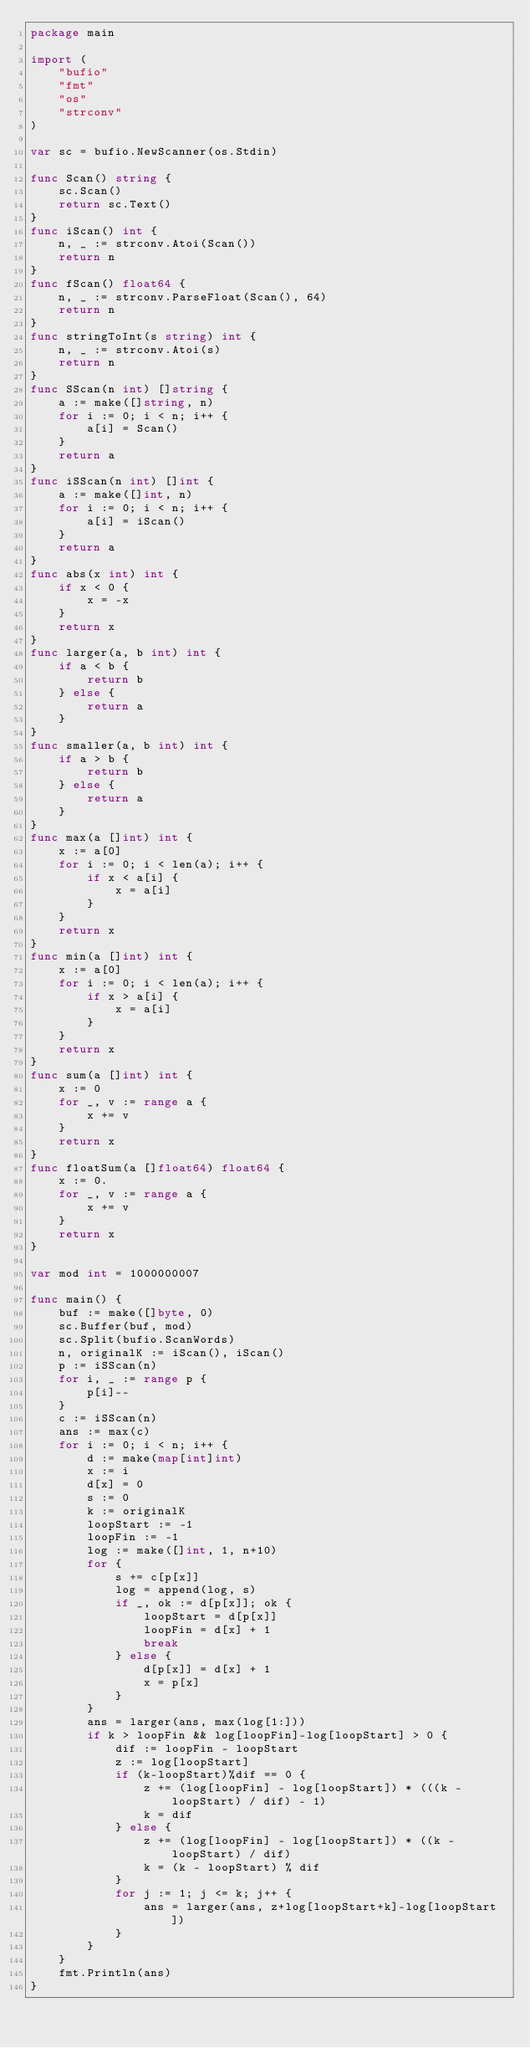Convert code to text. <code><loc_0><loc_0><loc_500><loc_500><_Go_>package main

import (
	"bufio"
	"fmt"
	"os"
	"strconv"
)

var sc = bufio.NewScanner(os.Stdin)

func Scan() string {
	sc.Scan()
	return sc.Text()
}
func iScan() int {
	n, _ := strconv.Atoi(Scan())
	return n
}
func fScan() float64 {
	n, _ := strconv.ParseFloat(Scan(), 64)
	return n
}
func stringToInt(s string) int {
	n, _ := strconv.Atoi(s)
	return n
}
func SScan(n int) []string {
	a := make([]string, n)
	for i := 0; i < n; i++ {
		a[i] = Scan()
	}
	return a
}
func iSScan(n int) []int {
	a := make([]int, n)
	for i := 0; i < n; i++ {
		a[i] = iScan()
	}
	return a
}
func abs(x int) int {
	if x < 0 {
		x = -x
	}
	return x
}
func larger(a, b int) int {
	if a < b {
		return b
	} else {
		return a
	}
}
func smaller(a, b int) int {
	if a > b {
		return b
	} else {
		return a
	}
}
func max(a []int) int {
	x := a[0]
	for i := 0; i < len(a); i++ {
		if x < a[i] {
			x = a[i]
		}
	}
	return x
}
func min(a []int) int {
	x := a[0]
	for i := 0; i < len(a); i++ {
		if x > a[i] {
			x = a[i]
		}
	}
	return x
}
func sum(a []int) int {
	x := 0
	for _, v := range a {
		x += v
	}
	return x
}
func floatSum(a []float64) float64 {
	x := 0.
	for _, v := range a {
		x += v
	}
	return x
}

var mod int = 1000000007

func main() {
	buf := make([]byte, 0)
	sc.Buffer(buf, mod)
	sc.Split(bufio.ScanWords)
	n, originalK := iScan(), iScan()
	p := iSScan(n)
	for i, _ := range p {
		p[i]--
	}
	c := iSScan(n)
	ans := max(c)
	for i := 0; i < n; i++ {
		d := make(map[int]int)
		x := i
		d[x] = 0
		s := 0
		k := originalK
		loopStart := -1
		loopFin := -1
		log := make([]int, 1, n+10)
		for {
			s += c[p[x]]
			log = append(log, s)
			if _, ok := d[p[x]]; ok {
				loopStart = d[p[x]]
				loopFin = d[x] + 1
				break
			} else {
				d[p[x]] = d[x] + 1
				x = p[x]
			}
		}
		ans = larger(ans, max(log[1:]))
		if k > loopFin && log[loopFin]-log[loopStart] > 0 {
			dif := loopFin - loopStart
			z := log[loopStart]
			if (k-loopStart)%dif == 0 {
				z += (log[loopFin] - log[loopStart]) * (((k - loopStart) / dif) - 1)
				k = dif
			} else {
				z += (log[loopFin] - log[loopStart]) * ((k - loopStart) / dif)
				k = (k - loopStart) % dif
			}
			for j := 1; j <= k; j++ {
				ans = larger(ans, z+log[loopStart+k]-log[loopStart])
			}
		}
	}
	fmt.Println(ans)
}
</code> 